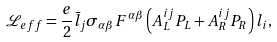Convert formula to latex. <formula><loc_0><loc_0><loc_500><loc_500>\mathcal { L } _ { e f f } = \frac { e } { 2 } \bar { l } _ { j } \sigma _ { \alpha \beta } F ^ { \alpha \beta } \left ( A _ { L } ^ { i j } P _ { L } + A _ { R } ^ { i j } P _ { R } \right ) l _ { i } ,</formula> 